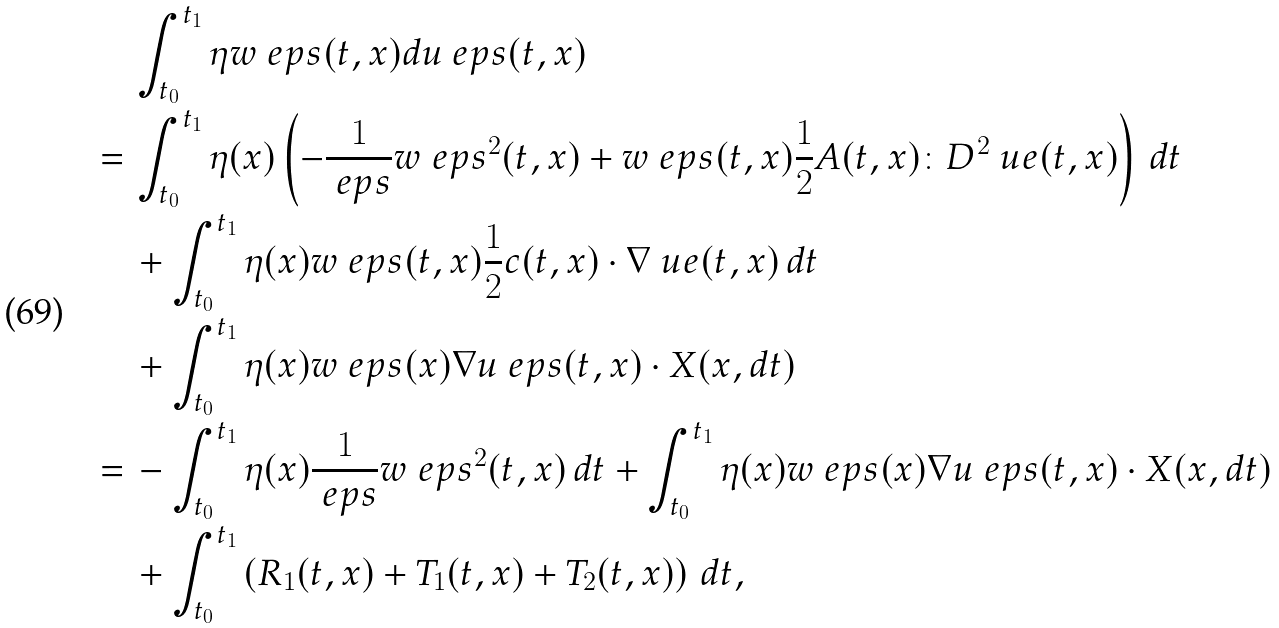Convert formula to latex. <formula><loc_0><loc_0><loc_500><loc_500>& \int _ { t _ { 0 } } ^ { t _ { 1 } } \eta w _ { \ } e p s ( t , x ) d u _ { \ } e p s ( t , x ) \\ = \, & \int _ { t _ { 0 } } ^ { t _ { 1 } } \eta ( x ) \left ( - \frac { 1 } { \ e p s } w _ { \ } e p s ^ { 2 } ( t , x ) + w _ { \ } e p s ( t , x ) \frac { 1 } { 2 } A ( t , x ) \colon D ^ { 2 } \ u e ( t , x ) \right ) \, d t \\ & + \int _ { t _ { 0 } } ^ { t _ { 1 } } \eta ( x ) w _ { \ } e p s ( t , x ) \frac { 1 } { 2 } c ( t , x ) \cdot \nabla \ u e ( t , x ) \, d t \\ & + \int _ { t _ { 0 } } ^ { t _ { 1 } } \eta ( x ) w _ { \ } e p s ( x ) \nabla u _ { \ } e p s ( t , x ) \cdot X ( x , d t ) \\ = \, & - \int _ { t _ { 0 } } ^ { t _ { 1 } } \eta ( x ) \frac { 1 } { \ e p s } w _ { \ } e p s ^ { 2 } ( t , x ) \, d t + \int _ { t _ { 0 } } ^ { t _ { 1 } } \eta ( x ) w _ { \ } e p s ( x ) \nabla u _ { \ } e p s ( t , x ) \cdot X ( x , d t ) \\ & + \int _ { t _ { 0 } } ^ { t _ { 1 } } \left ( R _ { 1 } ( t , x ) + T _ { 1 } ( t , x ) + T _ { 2 } ( t , x ) \right ) \, d t ,</formula> 